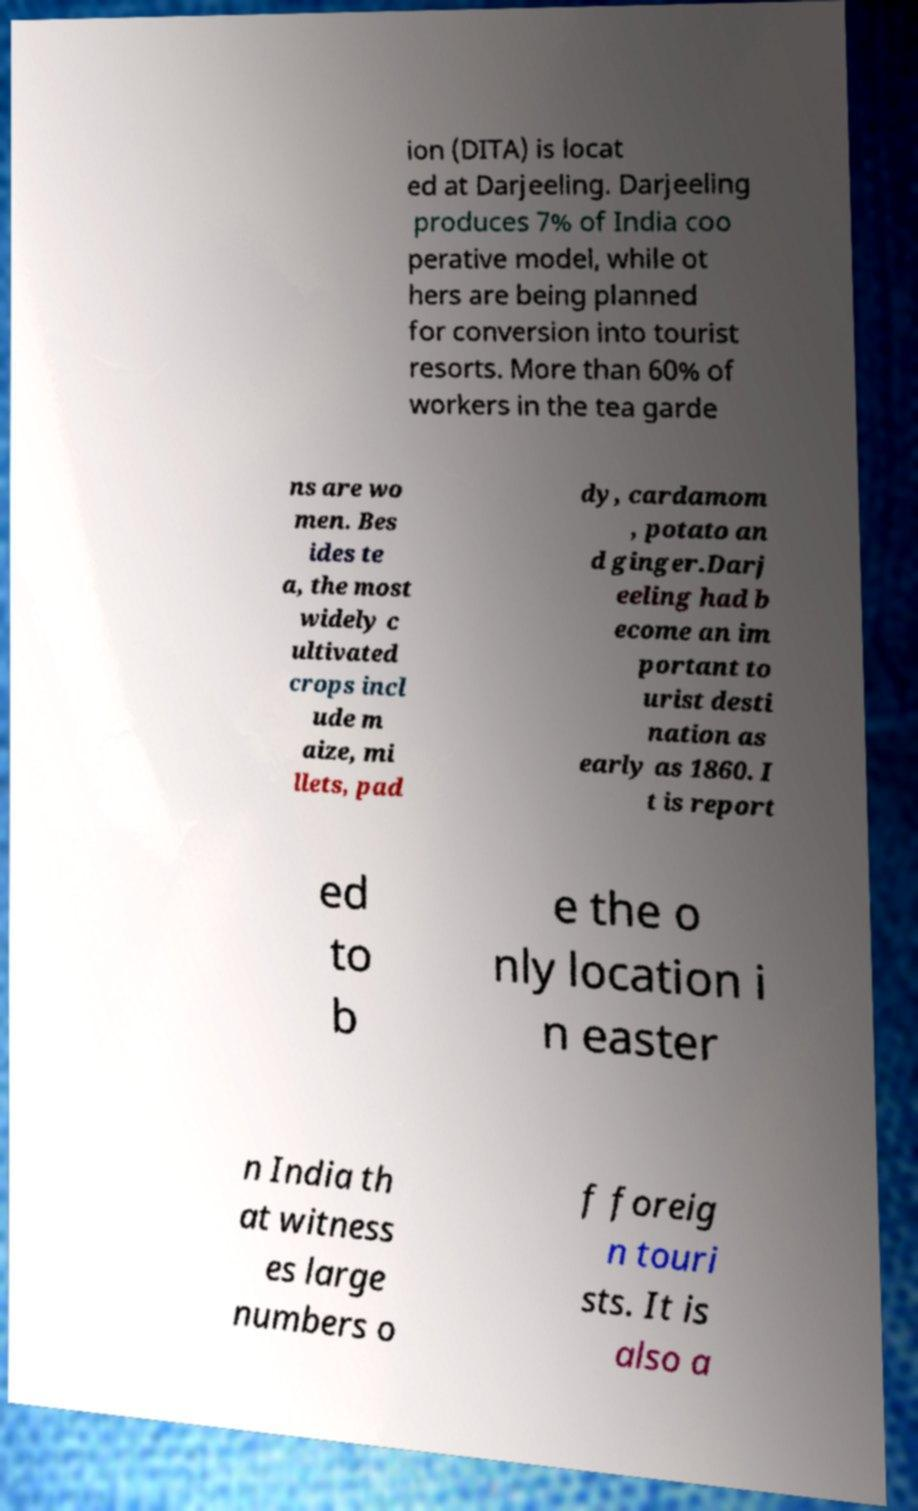Could you extract and type out the text from this image? ion (DITA) is locat ed at Darjeeling. Darjeeling produces 7% of India coo perative model, while ot hers are being planned for conversion into tourist resorts. More than 60% of workers in the tea garde ns are wo men. Bes ides te a, the most widely c ultivated crops incl ude m aize, mi llets, pad dy, cardamom , potato an d ginger.Darj eeling had b ecome an im portant to urist desti nation as early as 1860. I t is report ed to b e the o nly location i n easter n India th at witness es large numbers o f foreig n touri sts. It is also a 